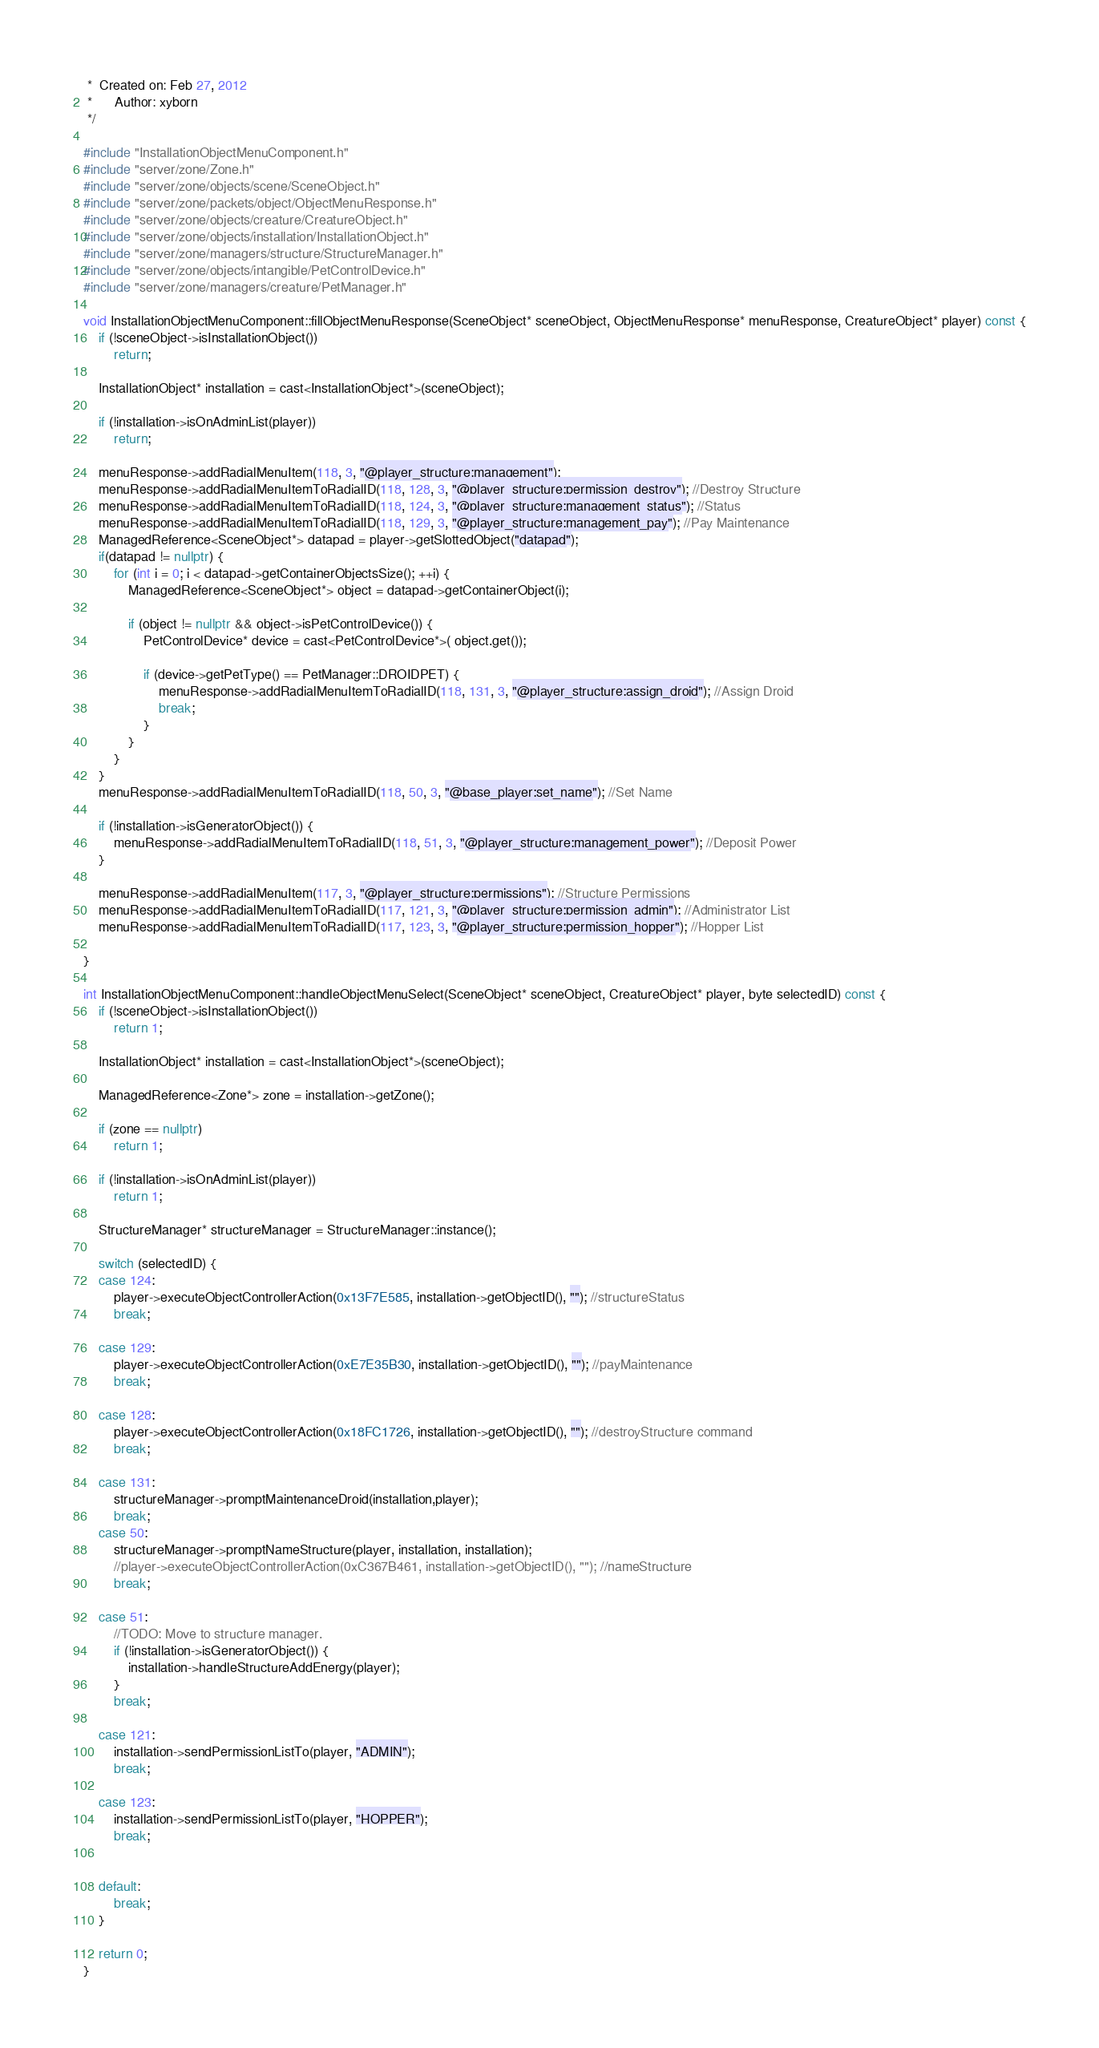<code> <loc_0><loc_0><loc_500><loc_500><_C++_> *  Created on: Feb 27, 2012
 *      Author: xyborn
 */

#include "InstallationObjectMenuComponent.h"
#include "server/zone/Zone.h"
#include "server/zone/objects/scene/SceneObject.h"
#include "server/zone/packets/object/ObjectMenuResponse.h"
#include "server/zone/objects/creature/CreatureObject.h"
#include "server/zone/objects/installation/InstallationObject.h"
#include "server/zone/managers/structure/StructureManager.h"
#include "server/zone/objects/intangible/PetControlDevice.h"
#include "server/zone/managers/creature/PetManager.h"

void InstallationObjectMenuComponent::fillObjectMenuResponse(SceneObject* sceneObject, ObjectMenuResponse* menuResponse, CreatureObject* player) const {
	if (!sceneObject->isInstallationObject())
		return;

	InstallationObject* installation = cast<InstallationObject*>(sceneObject);

	if (!installation->isOnAdminList(player))
		return;

	menuResponse->addRadialMenuItem(118, 3, "@player_structure:management");
	menuResponse->addRadialMenuItemToRadialID(118, 128, 3, "@player_structure:permission_destroy"); //Destroy Structure
	menuResponse->addRadialMenuItemToRadialID(118, 124, 3, "@player_structure:management_status"); //Status
	menuResponse->addRadialMenuItemToRadialID(118, 129, 3, "@player_structure:management_pay"); //Pay Maintenance
	ManagedReference<SceneObject*> datapad = player->getSlottedObject("datapad");
	if(datapad != nullptr) {
		for (int i = 0; i < datapad->getContainerObjectsSize(); ++i) {
			ManagedReference<SceneObject*> object = datapad->getContainerObject(i);

			if (object != nullptr && object->isPetControlDevice()) {
				PetControlDevice* device = cast<PetControlDevice*>( object.get());

				if (device->getPetType() == PetManager::DROIDPET) {
					menuResponse->addRadialMenuItemToRadialID(118, 131, 3, "@player_structure:assign_droid"); //Assign Droid
					break;
				}
			}
		}
	}
	menuResponse->addRadialMenuItemToRadialID(118, 50, 3, "@base_player:set_name"); //Set Name

	if (!installation->isGeneratorObject()) {
		menuResponse->addRadialMenuItemToRadialID(118, 51, 3, "@player_structure:management_power"); //Deposit Power
	}

	menuResponse->addRadialMenuItem(117, 3, "@player_structure:permissions"); //Structure Permissions
	menuResponse->addRadialMenuItemToRadialID(117, 121, 3, "@player_structure:permission_admin"); //Administrator List
	menuResponse->addRadialMenuItemToRadialID(117, 123, 3, "@player_structure:permission_hopper"); //Hopper List

}

int InstallationObjectMenuComponent::handleObjectMenuSelect(SceneObject* sceneObject, CreatureObject* player, byte selectedID) const {
	if (!sceneObject->isInstallationObject())
		return 1;

	InstallationObject* installation = cast<InstallationObject*>(sceneObject);

	ManagedReference<Zone*> zone = installation->getZone();

	if (zone == nullptr)
		return 1;

	if (!installation->isOnAdminList(player))
		return 1;

	StructureManager* structureManager = StructureManager::instance();

	switch (selectedID) {
	case 124:
		player->executeObjectControllerAction(0x13F7E585, installation->getObjectID(), ""); //structureStatus
		break;

	case 129:
		player->executeObjectControllerAction(0xE7E35B30, installation->getObjectID(), ""); //payMaintenance
		break;

	case 128:
		player->executeObjectControllerAction(0x18FC1726, installation->getObjectID(), ""); //destroyStructure command
		break;

	case 131:
		structureManager->promptMaintenanceDroid(installation,player);
		break;
	case 50:
		structureManager->promptNameStructure(player, installation, installation);
		//player->executeObjectControllerAction(0xC367B461, installation->getObjectID(), ""); //nameStructure
		break;

	case 51:
		//TODO: Move to structure manager.
		if (!installation->isGeneratorObject()) {
			installation->handleStructureAddEnergy(player);
		}
		break;

	case 121:
		installation->sendPermissionListTo(player, "ADMIN");
		break;

	case 123:
		installation->sendPermissionListTo(player, "HOPPER");
		break;


	default:
		break;
	}

	return 0;
}


</code> 